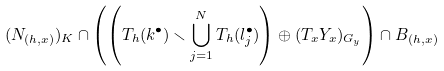Convert formula to latex. <formula><loc_0><loc_0><loc_500><loc_500>( N _ { ( h , x ) } ) _ { K } \cap \left ( \left ( T _ { h } ( k ^ { \bullet } ) \smallsetminus \bigcup _ { j = 1 } ^ { N } T _ { h } ( l _ { j } ^ { \bullet } ) \right ) \oplus ( T _ { x } Y _ { x } ) _ { G _ { y } } \right ) \cap B _ { ( h , x ) }</formula> 